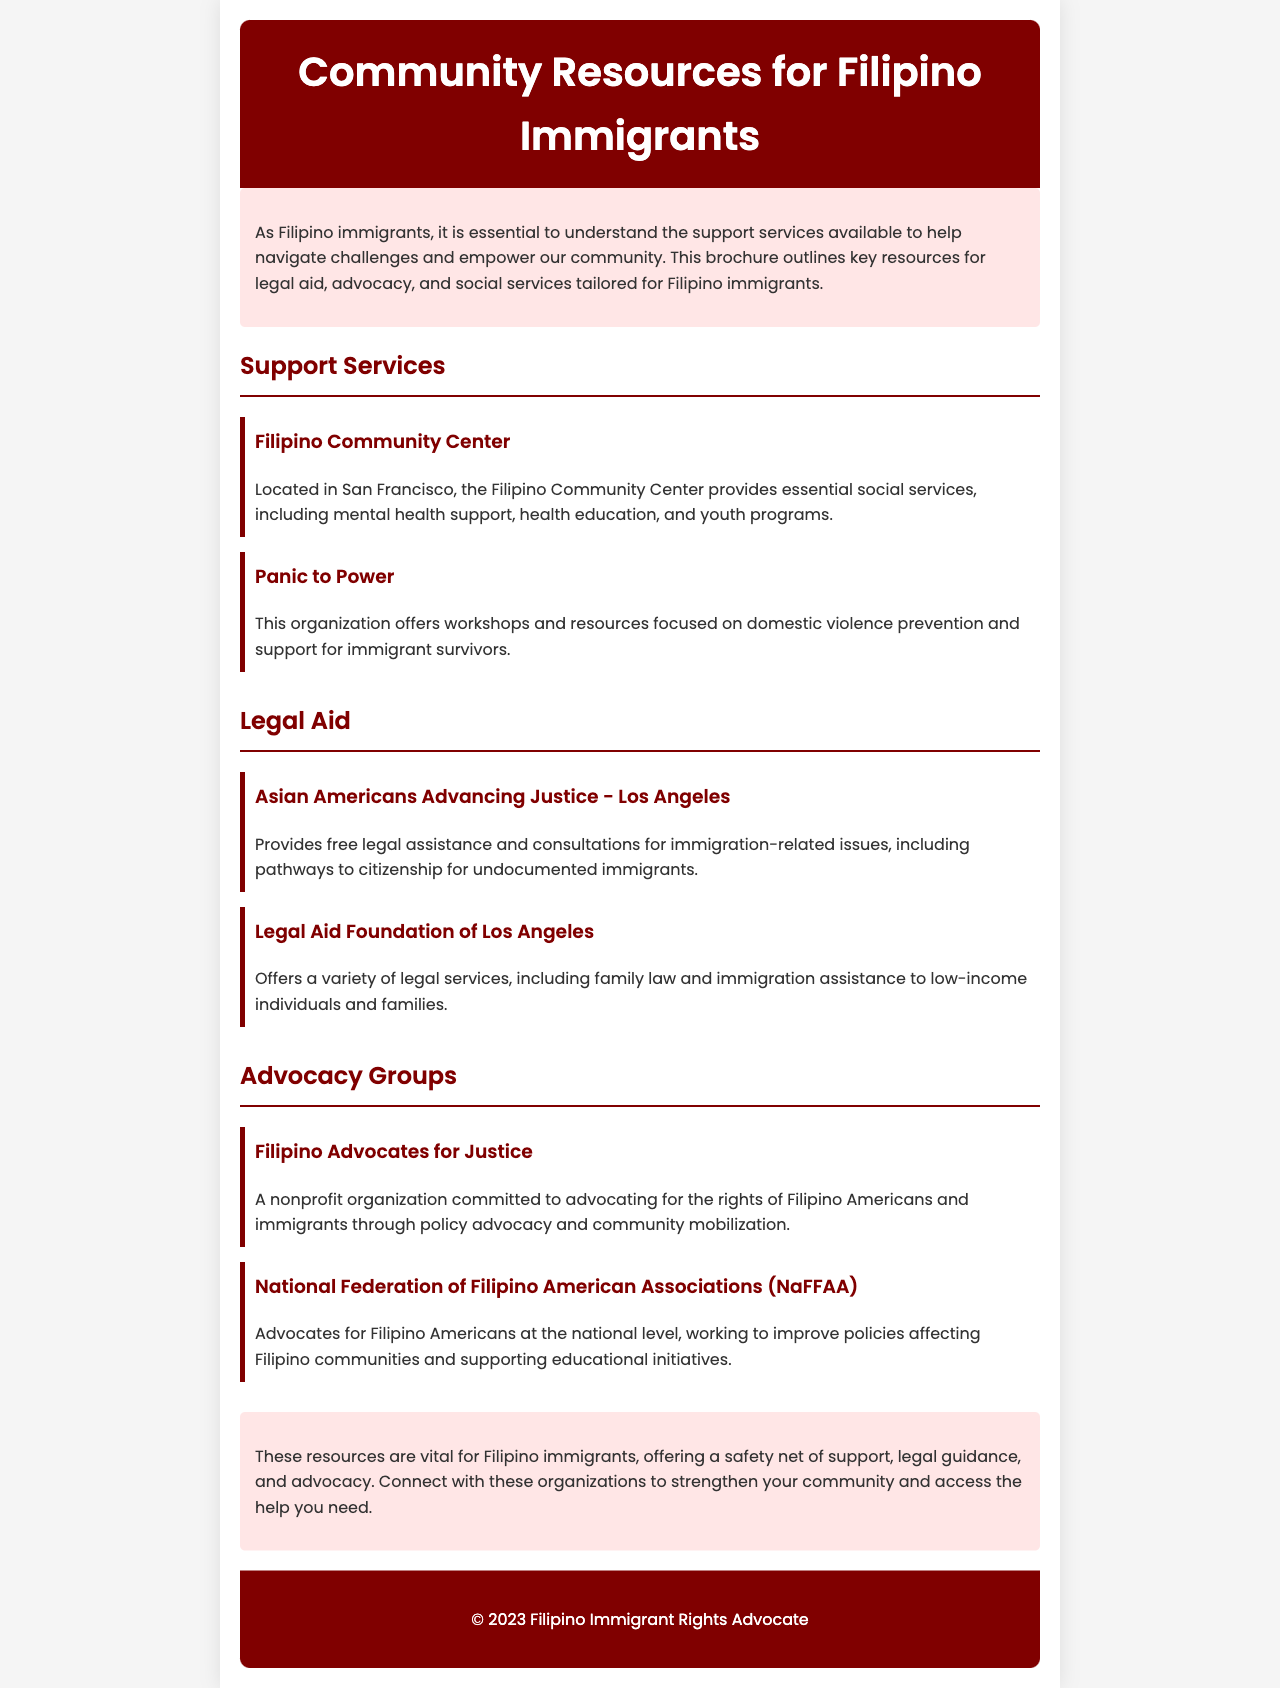What is the title of the brochure? The title is clearly stated at the top of the document.
Answer: Community Resources for Filipino Immigrants What is one service offered by the Filipino Community Center? The Filipino Community Center provides essential social services including mental health support.
Answer: mental health support Which organization focuses on domestic violence prevention? The document specifies which organization provides resources centered on domestic violence.
Answer: Panic to Power Where is Asian Americans Advancing Justice - Los Angeles located? The document implies the geographic focus of the organization.
Answer: Los Angeles What type of assistance does the Legal Aid Foundation of Los Angeles provide? The document outlines the legal services offered by this foundation.
Answer: immigration assistance What is the main focus of Filipino Advocates for Justice? The document describes the mission of this nonprofit organization.
Answer: advocating for the rights of Filipino Americans and immigrants Which group works at the national level for Filipino Americans? The brochure mentions the name of this national advocacy group.
Answer: National Federation of Filipino American Associations (NaFFAA) What color is the header of the brochure? The header's background color is specifically mentioned in the design section of the document.
Answer: #800000 